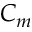<formula> <loc_0><loc_0><loc_500><loc_500>C _ { m }</formula> 